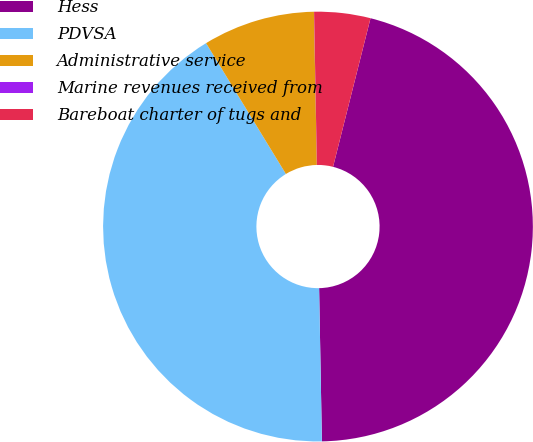Convert chart. <chart><loc_0><loc_0><loc_500><loc_500><pie_chart><fcel>Hess<fcel>PDVSA<fcel>Administrative service<fcel>Marine revenues received from<fcel>Bareboat charter of tugs and<nl><fcel>45.78%<fcel>41.57%<fcel>8.42%<fcel>0.01%<fcel>4.22%<nl></chart> 